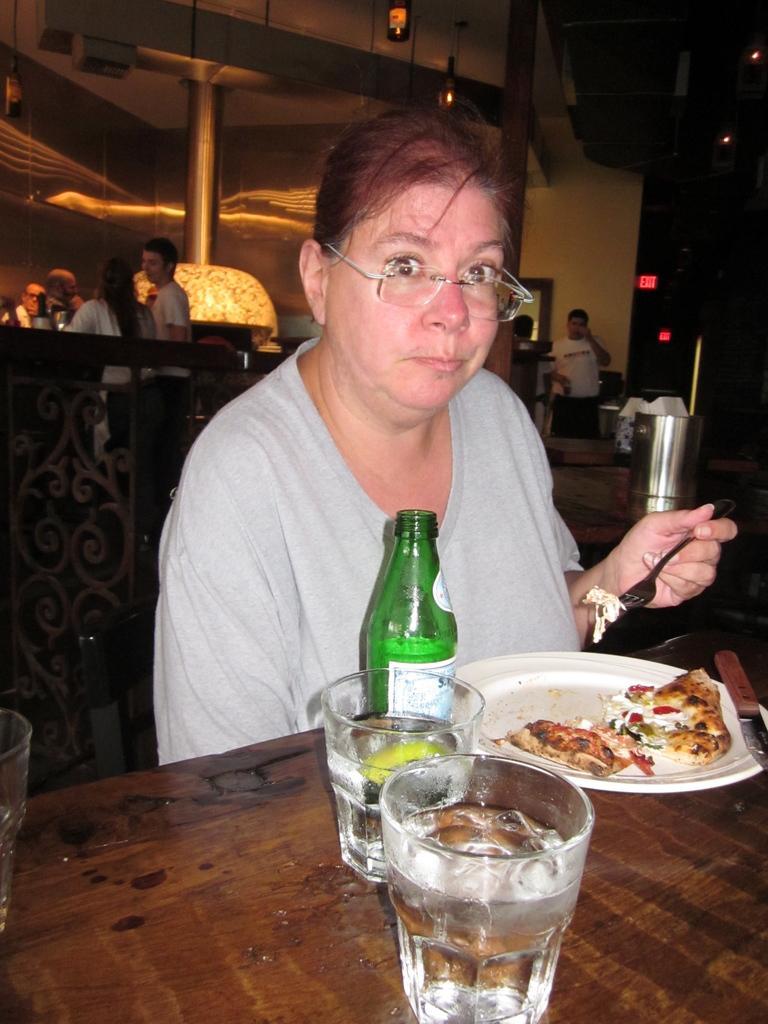Could you give a brief overview of what you see in this image? In this image i can see a person sitting on a chair in front of a table, holding a fork. On the table i can see 2 glasses, a bottle, a plate and a pizza. In the background i can see few people, a pillar, the wall, a board and the roof. 